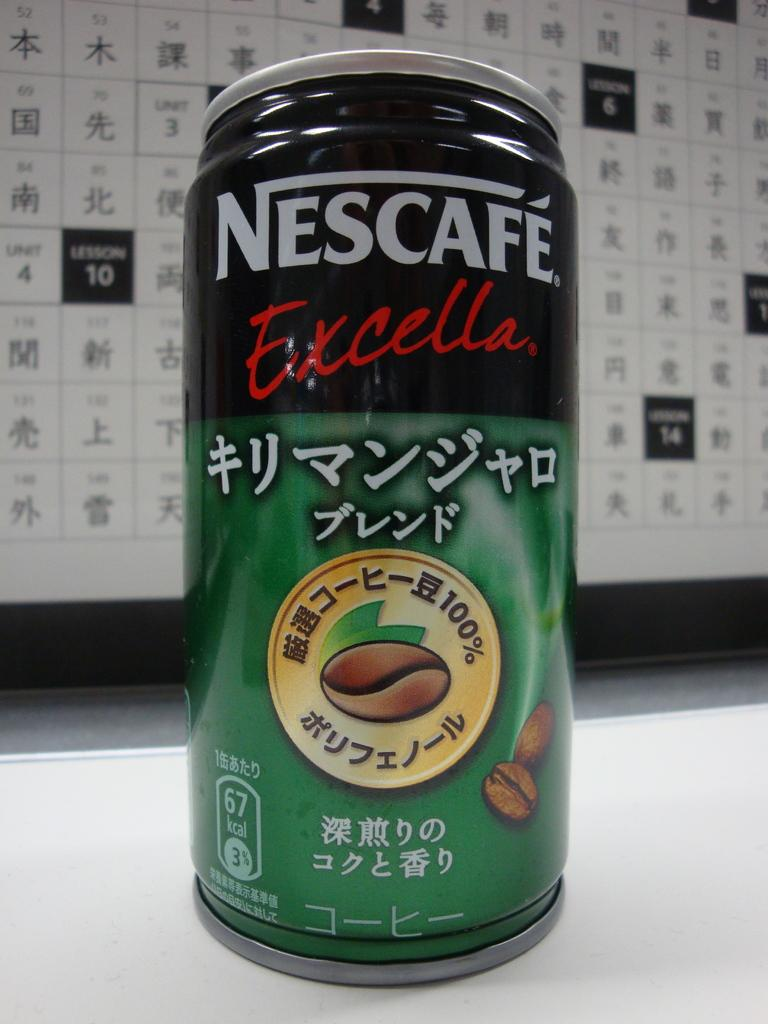<image>
Relay a brief, clear account of the picture shown. A bottle of Nescafe Excella has asian writin on it. 